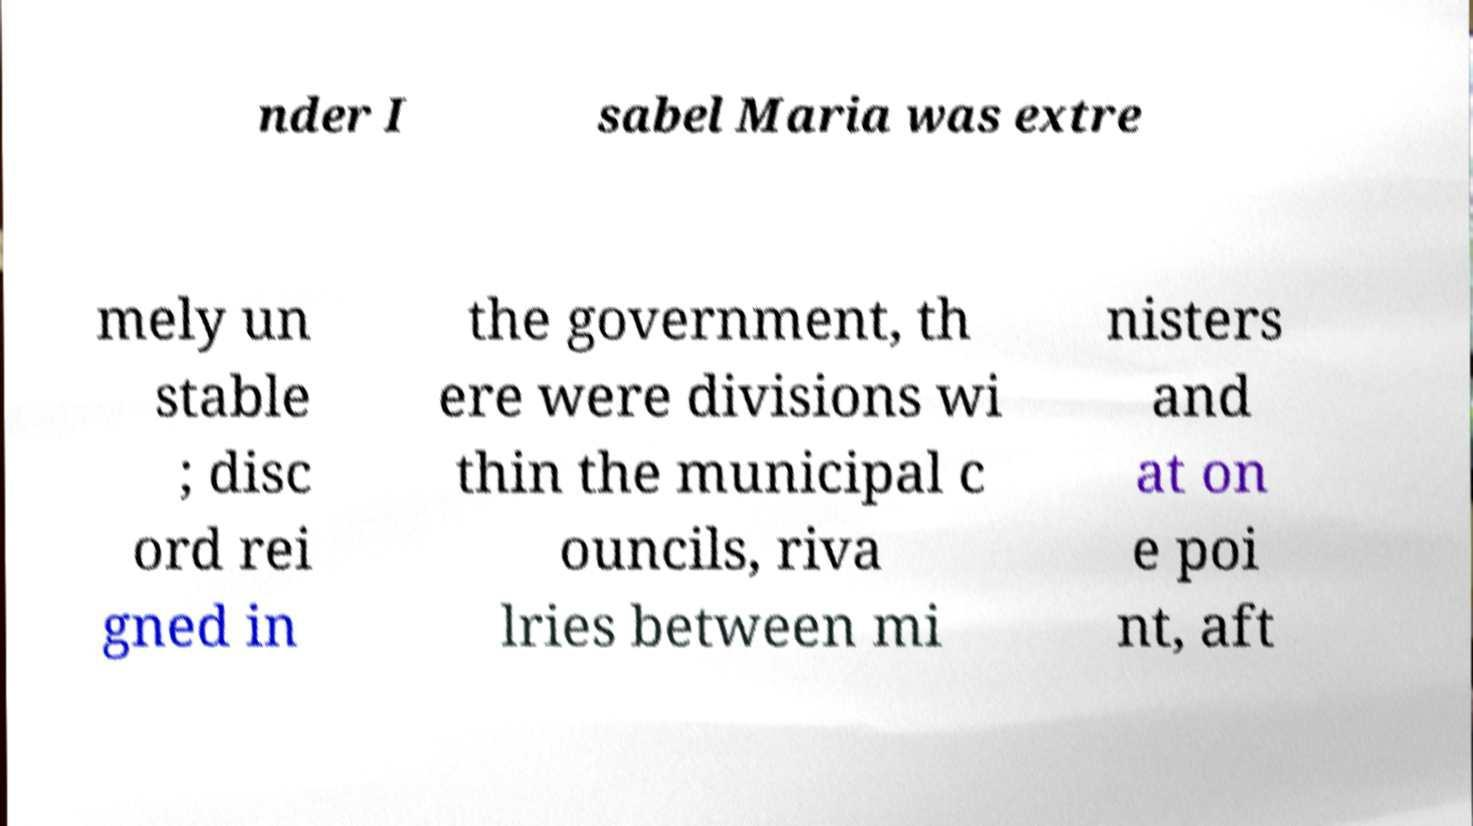Please read and relay the text visible in this image. What does it say? nder I sabel Maria was extre mely un stable ; disc ord rei gned in the government, th ere were divisions wi thin the municipal c ouncils, riva lries between mi nisters and at on e poi nt, aft 